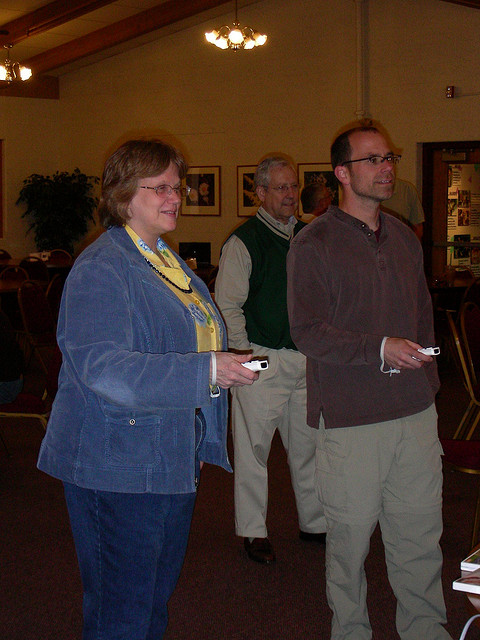<image>What kind of celebration is this? It is unclear what kind of celebration this is as it can be a birthday, a family gathering, or even a game night. What kind of celebration is this? It is ambiguous what kind of celebration it is. It can be a holiday gathering, a family night, playing video games, or a birthday celebration. 